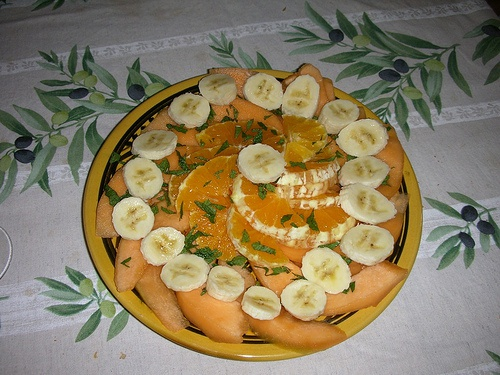Describe the objects in this image and their specific colors. I can see dining table in darkgray, gray, olive, tan, and black tones, banana in black and tan tones, banana in black and tan tones, orange in black, olive, and maroon tones, and orange in black, orange, tan, and khaki tones in this image. 